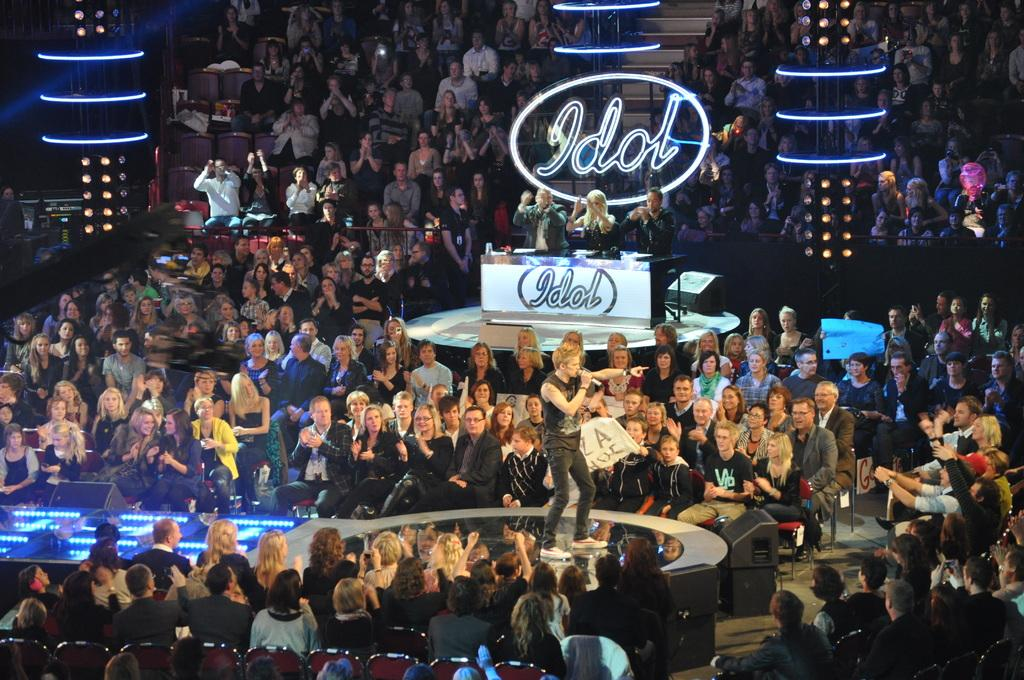What are the people in the image doing? The people in the image are sitting on chairs. What other furniture can be seen in the image? There is a desk in the image. What is the man in the image doing? The man is standing in the image. What object is the man holding in the image? The man is holding a microphone in the image. What type of trade is being conducted in the image? There is no indication of any trade being conducted in the image. What color is the tail of the man in the image? There is no mention of a tail on the man in the image, as humans do not have tails. 